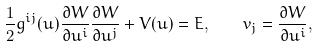<formula> <loc_0><loc_0><loc_500><loc_500>\frac { 1 } { 2 } g ^ { i j } ( { u } ) \frac { \partial W } { \partial u ^ { i } } \frac { \partial W } { \partial u ^ { j } } + V ( { u } ) = E , \quad v _ { j } = \frac { \partial W } { \partial u ^ { i } } ,</formula> 